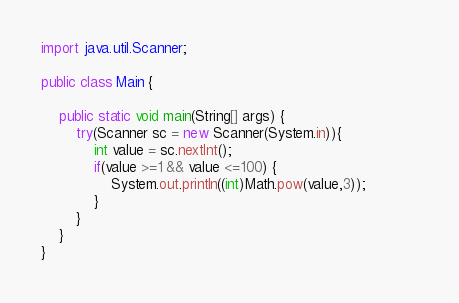Convert code to text. <code><loc_0><loc_0><loc_500><loc_500><_Java_>import java.util.Scanner;

public class Main {

	public static void main(String[] args) {
		try(Scanner sc = new Scanner(System.in)){
			int value = sc.nextInt();
			if(value >=1 && value <=100) {
				System.out.println((int)Math.pow(value,3));			
			}
		}
	}
}</code> 